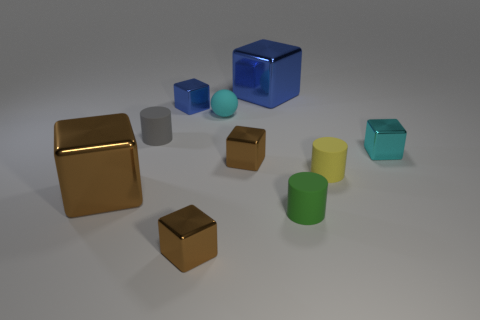How many brown blocks must be subtracted to get 1 brown blocks? 2 Subtract all brown cylinders. How many brown cubes are left? 3 Subtract 2 blocks. How many blocks are left? 4 Subtract all cyan cubes. How many cubes are left? 5 Subtract all cyan metal blocks. How many blocks are left? 5 Subtract all yellow blocks. Subtract all gray cylinders. How many blocks are left? 6 Subtract all spheres. How many objects are left? 9 Subtract 0 green blocks. How many objects are left? 10 Subtract all spheres. Subtract all small green rubber objects. How many objects are left? 8 Add 9 tiny green matte cylinders. How many tiny green matte cylinders are left? 10 